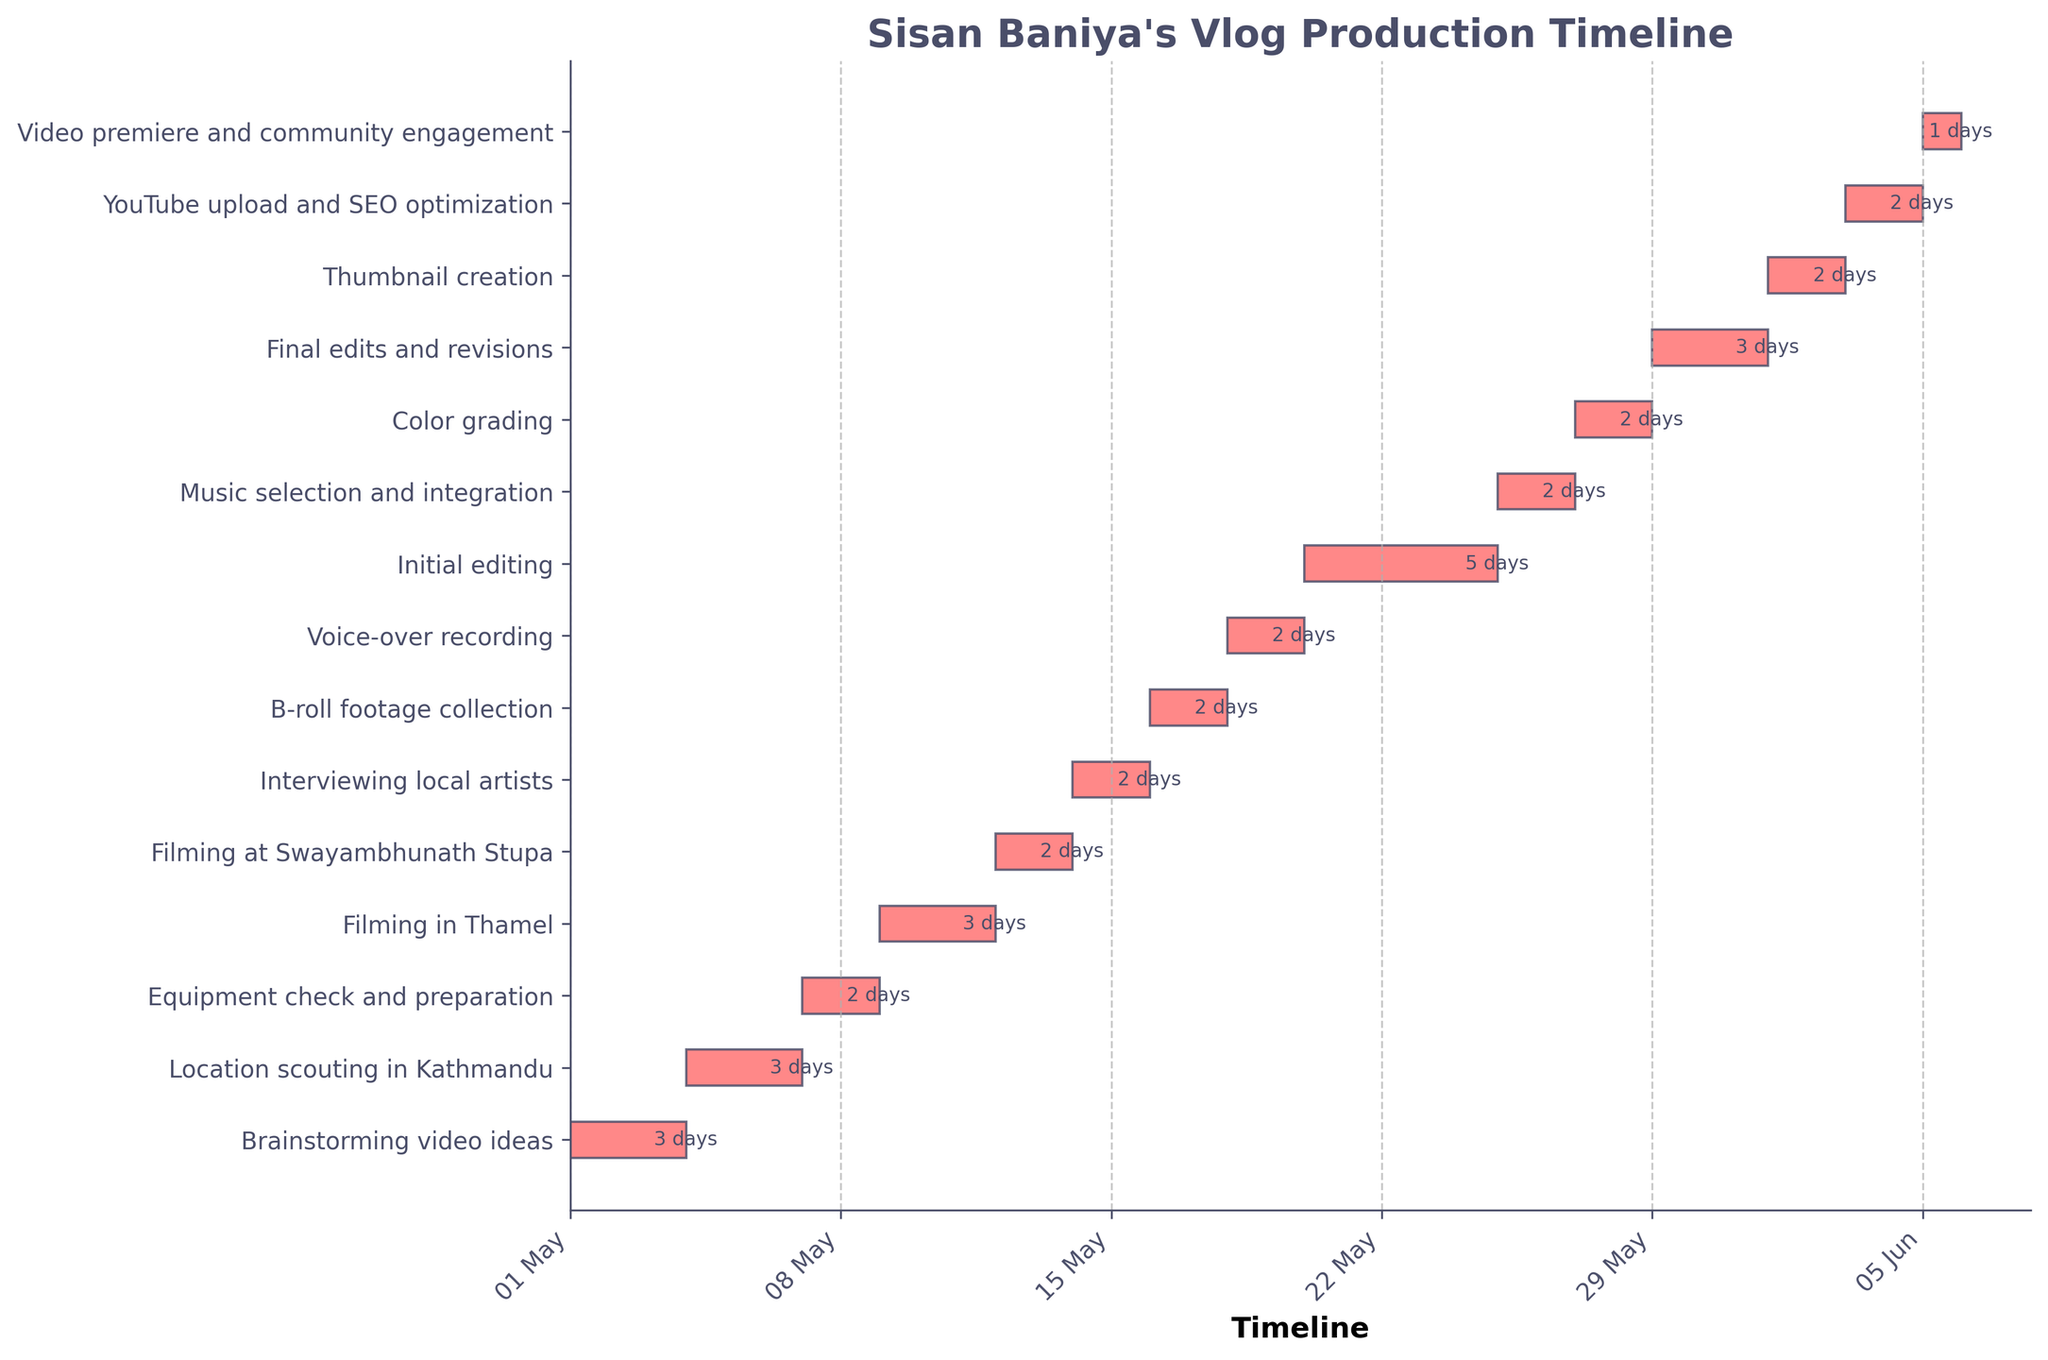What is the title of the Gantt chart? The title is typically displayed at the top of the figure and provides a summary of what the chart represents. In this case, it is located at the top of the Gantt chart.
Answer: "Sisan Baniya's Vlog Production Timeline" When does the 'Filming in Thamel' task start and end? Look at the corresponding bar for 'Filming in Thamel' on the y-axis. The bar's left edge marks the start date, and the right edge marks the end date.
Answer: Starts on 2023-05-09 and ends on 2023-05-11 How many days are spent on 'Initial editing'? The duration of each task is typically noted on the right side of the corresponding bar. For 'Initial editing', check this annotation.
Answer: 5 days Are there any tasks that last only one day? If so, which ones? Examine the duration labels of each task to identify tasks that last only one day.
Answer: Yes, 'Video premiere and community engagement' lasts one day Which task immediately follows 'Interviewing local artists'? Look at the timeline to find 'Interviewing local artists' and see which task starts immediately after it ends.
Answer: B-roll footage collection How long is the total duration from the start of the first task to the end of the last task? Find the start date of the first task and the end date of the last task, then count the days inclusive.
Answer: 36 days (from 2023-05-01 to 2023-06-05) Which filming task takes place right before 'Interviewing local artists'? Look at the y-axis and the timeline to find which task ends just before 'Interviewing local artists' begins.
Answer: Filming at Swayambhunath Stupa What is the duration of the task 'Music selection and integration'? The duration of this task can be found annotated next to its bar on the chart.
Answer: 2 days How many tasks are there in total? Count the number of bars on the Gantt chart, which corresponds to the number of tasks listed on the y-axis.
Answer: 14 tasks What tasks overlap exactly with 'Voice-over recording'? Identify the start and end dates of 'Voice-over recording' and see which other task bars overlap within this time frame on the x-axis.
Answer: No tasks overlap exactly with 'Voice-over recording' 